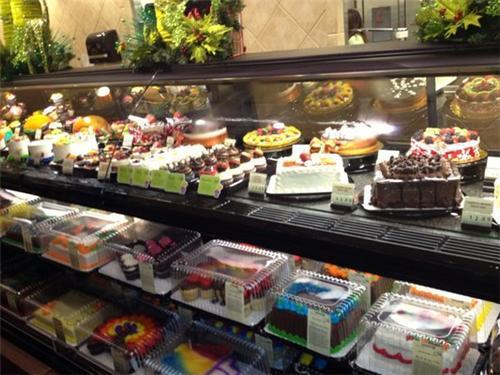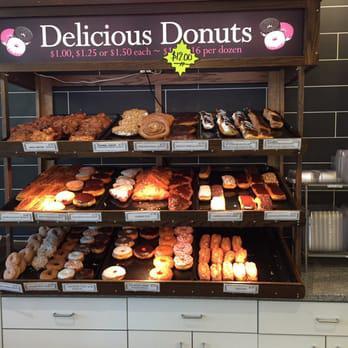The first image is the image on the left, the second image is the image on the right. For the images shown, is this caption "Floral arrangements are on a shelf somewhere above a glass display of bakery items." true? Answer yes or no. Yes. The first image is the image on the left, the second image is the image on the right. For the images displayed, is the sentence "There are labels for each group of pastries in at least one of the images." factually correct? Answer yes or no. Yes. 